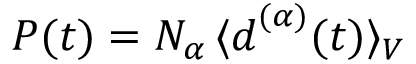<formula> <loc_0><loc_0><loc_500><loc_500>P ( t ) = N _ { \alpha } \, \langle d ^ { ( \alpha ) } ( t ) \rangle _ { V }</formula> 